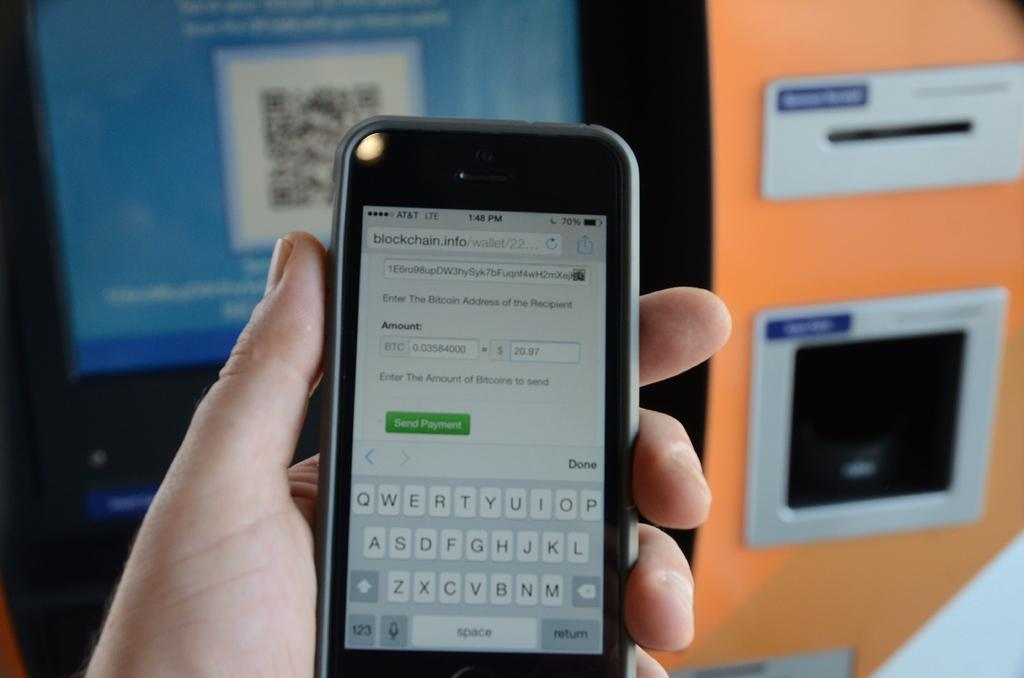<image>
Write a terse but informative summary of the picture. A hand holds a cellphone that has AT&T coverage says "Enter The Bitcoin Address of the Recipient". 